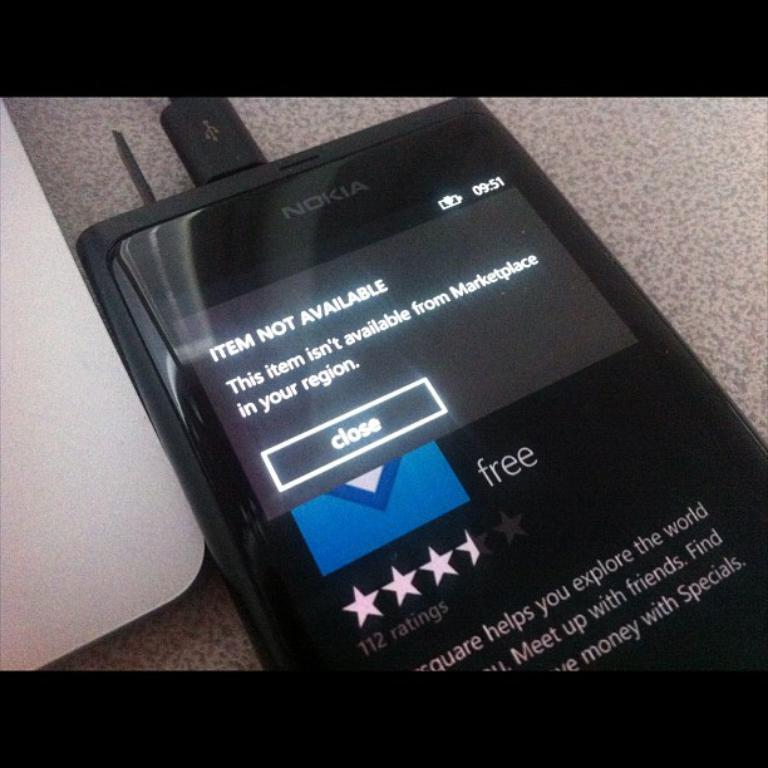<image>
Share a concise interpretation of the image provided. A black Nokia cell phone that is showing an item is not available in their region. 